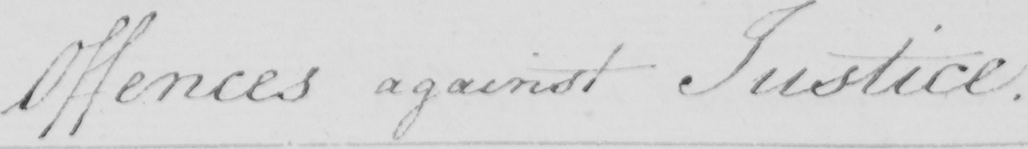Please transcribe the handwritten text in this image. Offences against Justice 